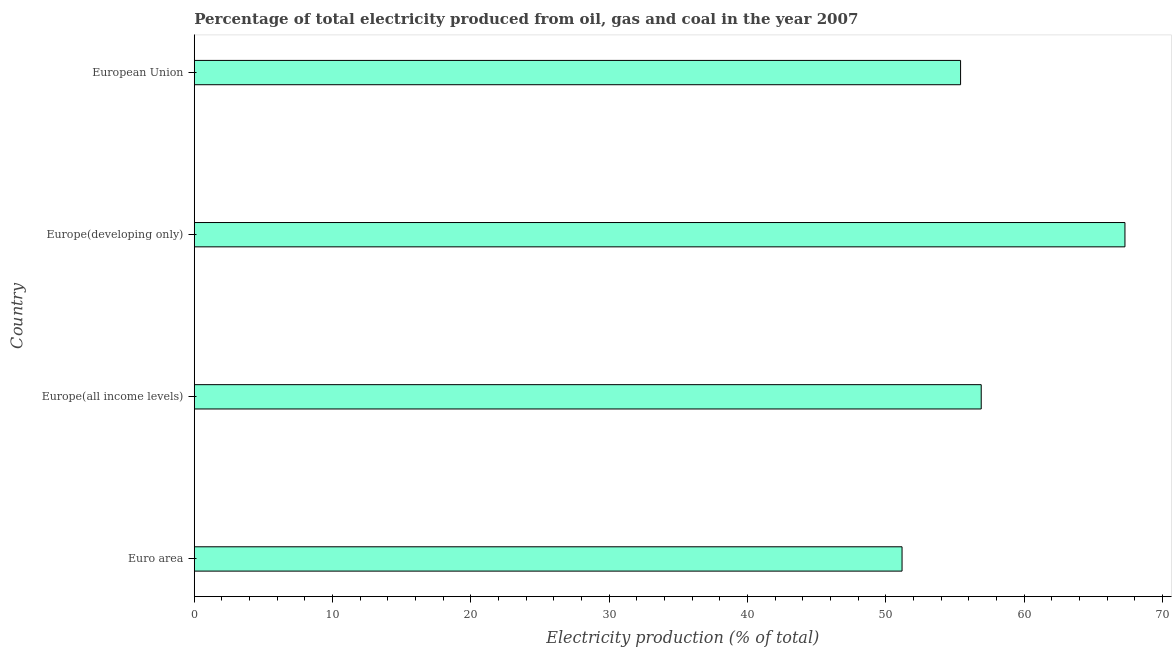What is the title of the graph?
Your answer should be compact. Percentage of total electricity produced from oil, gas and coal in the year 2007. What is the label or title of the X-axis?
Make the answer very short. Electricity production (% of total). What is the label or title of the Y-axis?
Your answer should be very brief. Country. What is the electricity production in Euro area?
Keep it short and to the point. 51.18. Across all countries, what is the maximum electricity production?
Ensure brevity in your answer.  67.29. Across all countries, what is the minimum electricity production?
Ensure brevity in your answer.  51.18. In which country was the electricity production maximum?
Offer a terse response. Europe(developing only). In which country was the electricity production minimum?
Provide a succinct answer. Euro area. What is the sum of the electricity production?
Keep it short and to the point. 230.78. What is the difference between the electricity production in Europe(all income levels) and European Union?
Your response must be concise. 1.49. What is the average electricity production per country?
Keep it short and to the point. 57.7. What is the median electricity production?
Offer a terse response. 56.15. In how many countries, is the electricity production greater than 46 %?
Provide a short and direct response. 4. What is the ratio of the electricity production in Europe(developing only) to that in European Union?
Keep it short and to the point. 1.22. Is the electricity production in Europe(all income levels) less than that in European Union?
Provide a short and direct response. No. What is the difference between the highest and the second highest electricity production?
Make the answer very short. 10.39. What is the difference between the highest and the lowest electricity production?
Give a very brief answer. 16.12. In how many countries, is the electricity production greater than the average electricity production taken over all countries?
Your answer should be compact. 1. Are all the bars in the graph horizontal?
Offer a terse response. Yes. How many countries are there in the graph?
Your response must be concise. 4. What is the difference between two consecutive major ticks on the X-axis?
Offer a very short reply. 10. Are the values on the major ticks of X-axis written in scientific E-notation?
Offer a very short reply. No. What is the Electricity production (% of total) of Euro area?
Offer a terse response. 51.18. What is the Electricity production (% of total) of Europe(all income levels)?
Make the answer very short. 56.9. What is the Electricity production (% of total) of Europe(developing only)?
Your answer should be compact. 67.29. What is the Electricity production (% of total) in European Union?
Keep it short and to the point. 55.41. What is the difference between the Electricity production (% of total) in Euro area and Europe(all income levels)?
Provide a succinct answer. -5.72. What is the difference between the Electricity production (% of total) in Euro area and Europe(developing only)?
Your answer should be compact. -16.12. What is the difference between the Electricity production (% of total) in Euro area and European Union?
Your response must be concise. -4.23. What is the difference between the Electricity production (% of total) in Europe(all income levels) and Europe(developing only)?
Make the answer very short. -10.39. What is the difference between the Electricity production (% of total) in Europe(all income levels) and European Union?
Offer a very short reply. 1.49. What is the difference between the Electricity production (% of total) in Europe(developing only) and European Union?
Keep it short and to the point. 11.89. What is the ratio of the Electricity production (% of total) in Euro area to that in Europe(all income levels)?
Keep it short and to the point. 0.9. What is the ratio of the Electricity production (% of total) in Euro area to that in Europe(developing only)?
Provide a succinct answer. 0.76. What is the ratio of the Electricity production (% of total) in Euro area to that in European Union?
Make the answer very short. 0.92. What is the ratio of the Electricity production (% of total) in Europe(all income levels) to that in Europe(developing only)?
Give a very brief answer. 0.85. What is the ratio of the Electricity production (% of total) in Europe(developing only) to that in European Union?
Give a very brief answer. 1.22. 